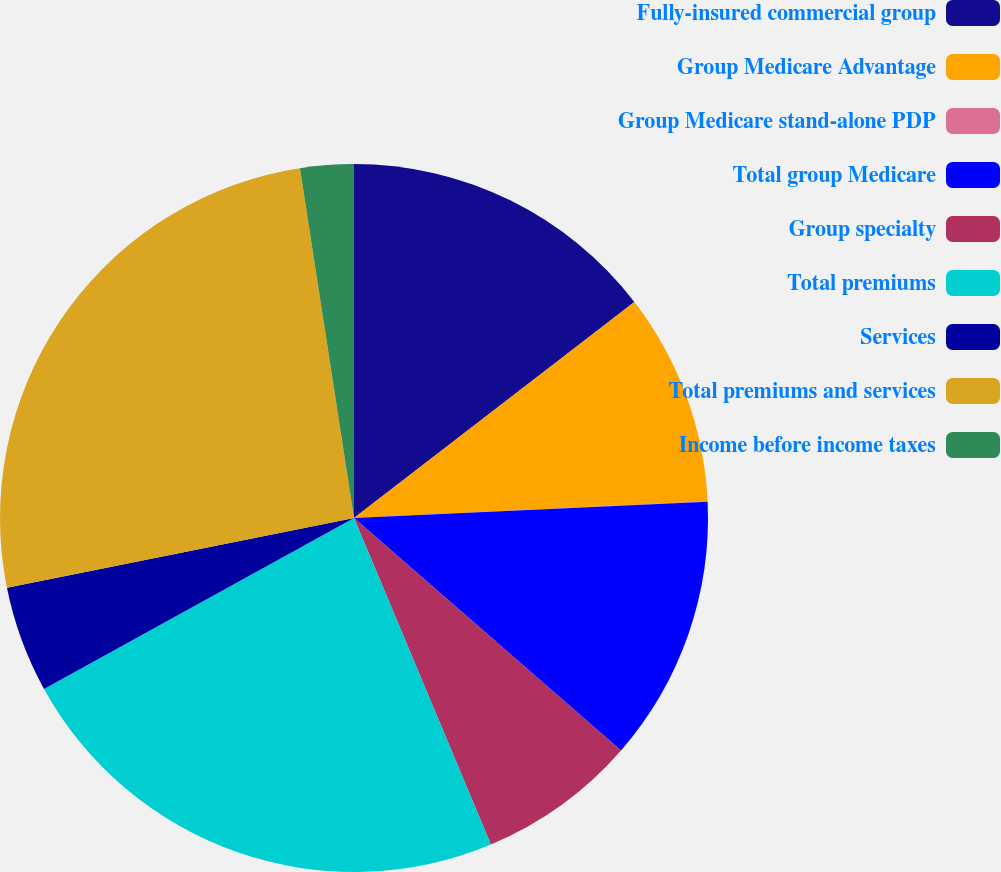Convert chart. <chart><loc_0><loc_0><loc_500><loc_500><pie_chart><fcel>Fully-insured commercial group<fcel>Group Medicare Advantage<fcel>Group Medicare stand-alone PDP<fcel>Total group Medicare<fcel>Group specialty<fcel>Total premiums<fcel>Services<fcel>Total premiums and services<fcel>Income before income taxes<nl><fcel>14.55%<fcel>9.7%<fcel>0.02%<fcel>12.13%<fcel>7.28%<fcel>23.3%<fcel>4.86%<fcel>25.72%<fcel>2.44%<nl></chart> 